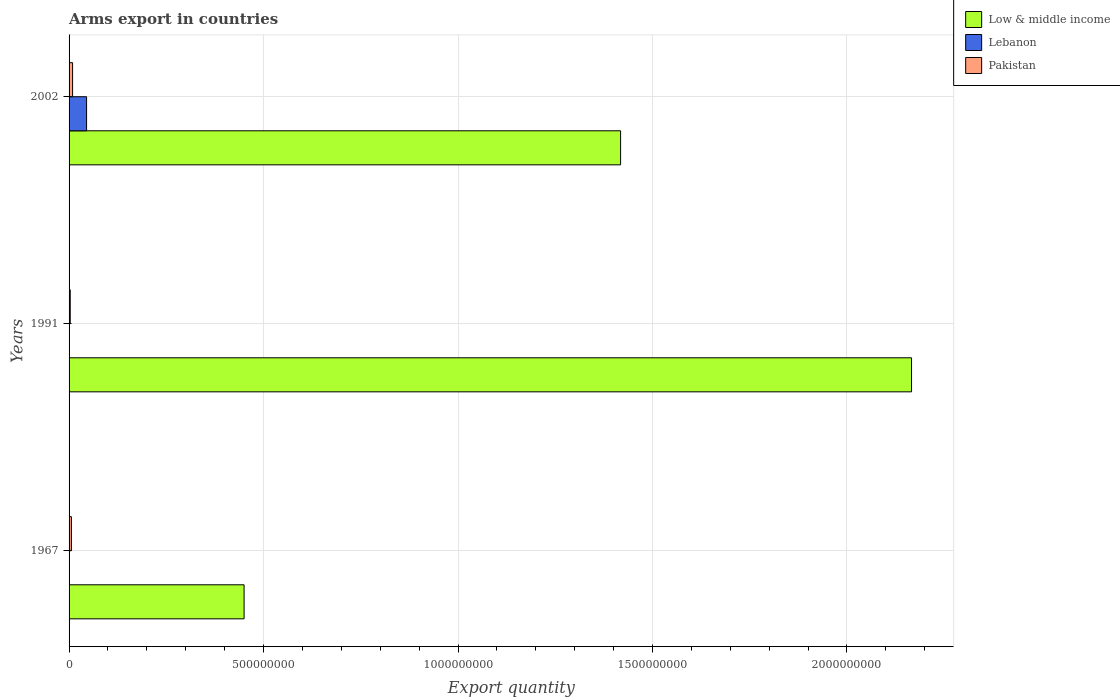How many groups of bars are there?
Offer a very short reply. 3. Are the number of bars per tick equal to the number of legend labels?
Ensure brevity in your answer.  Yes. Are the number of bars on each tick of the Y-axis equal?
Provide a short and direct response. Yes. How many bars are there on the 1st tick from the top?
Offer a terse response. 3. What is the label of the 1st group of bars from the top?
Your response must be concise. 2002. What is the total arms export in Lebanon in 2002?
Your response must be concise. 4.50e+07. Across all years, what is the maximum total arms export in Low & middle income?
Offer a terse response. 2.17e+09. Across all years, what is the minimum total arms export in Low & middle income?
Ensure brevity in your answer.  4.50e+08. In which year was the total arms export in Lebanon maximum?
Make the answer very short. 2002. In which year was the total arms export in Low & middle income minimum?
Your answer should be very brief. 1967. What is the total total arms export in Pakistan in the graph?
Your response must be concise. 1.80e+07. What is the difference between the total arms export in Lebanon in 1967 and that in 2002?
Give a very brief answer. -4.40e+07. What is the difference between the total arms export in Lebanon in 1967 and the total arms export in Pakistan in 2002?
Keep it short and to the point. -8.00e+06. What is the average total arms export in Low & middle income per year?
Your response must be concise. 1.34e+09. What is the ratio of the total arms export in Low & middle income in 1967 to that in 1991?
Provide a short and direct response. 0.21. Is the total arms export in Low & middle income in 1967 less than that in 1991?
Offer a terse response. Yes. Is the difference between the total arms export in Lebanon in 1967 and 1991 greater than the difference between the total arms export in Pakistan in 1967 and 1991?
Keep it short and to the point. No. What is the difference between the highest and the second highest total arms export in Lebanon?
Your answer should be very brief. 4.40e+07. What is the difference between the highest and the lowest total arms export in Pakistan?
Provide a succinct answer. 6.00e+06. Is the sum of the total arms export in Lebanon in 1967 and 2002 greater than the maximum total arms export in Pakistan across all years?
Make the answer very short. Yes. What does the 3rd bar from the top in 1991 represents?
Offer a terse response. Low & middle income. Is it the case that in every year, the sum of the total arms export in Lebanon and total arms export in Low & middle income is greater than the total arms export in Pakistan?
Provide a succinct answer. Yes. Are all the bars in the graph horizontal?
Ensure brevity in your answer.  Yes. How many years are there in the graph?
Keep it short and to the point. 3. What is the difference between two consecutive major ticks on the X-axis?
Make the answer very short. 5.00e+08. Does the graph contain any zero values?
Give a very brief answer. No. Does the graph contain grids?
Keep it short and to the point. Yes. How are the legend labels stacked?
Keep it short and to the point. Vertical. What is the title of the graph?
Provide a succinct answer. Arms export in countries. Does "Northern Mariana Islands" appear as one of the legend labels in the graph?
Your response must be concise. No. What is the label or title of the X-axis?
Provide a succinct answer. Export quantity. What is the Export quantity of Low & middle income in 1967?
Keep it short and to the point. 4.50e+08. What is the Export quantity of Lebanon in 1967?
Your response must be concise. 1.00e+06. What is the Export quantity in Low & middle income in 1991?
Your answer should be very brief. 2.17e+09. What is the Export quantity of Pakistan in 1991?
Keep it short and to the point. 3.00e+06. What is the Export quantity of Low & middle income in 2002?
Your answer should be very brief. 1.42e+09. What is the Export quantity in Lebanon in 2002?
Your response must be concise. 4.50e+07. What is the Export quantity in Pakistan in 2002?
Make the answer very short. 9.00e+06. Across all years, what is the maximum Export quantity of Low & middle income?
Ensure brevity in your answer.  2.17e+09. Across all years, what is the maximum Export quantity of Lebanon?
Provide a succinct answer. 4.50e+07. Across all years, what is the maximum Export quantity in Pakistan?
Provide a succinct answer. 9.00e+06. Across all years, what is the minimum Export quantity of Low & middle income?
Provide a short and direct response. 4.50e+08. Across all years, what is the minimum Export quantity of Pakistan?
Your answer should be compact. 3.00e+06. What is the total Export quantity of Low & middle income in the graph?
Offer a very short reply. 4.03e+09. What is the total Export quantity of Lebanon in the graph?
Your answer should be very brief. 4.70e+07. What is the total Export quantity of Pakistan in the graph?
Make the answer very short. 1.80e+07. What is the difference between the Export quantity of Low & middle income in 1967 and that in 1991?
Give a very brief answer. -1.72e+09. What is the difference between the Export quantity of Low & middle income in 1967 and that in 2002?
Your answer should be compact. -9.68e+08. What is the difference between the Export quantity of Lebanon in 1967 and that in 2002?
Keep it short and to the point. -4.40e+07. What is the difference between the Export quantity of Low & middle income in 1991 and that in 2002?
Offer a very short reply. 7.48e+08. What is the difference between the Export quantity in Lebanon in 1991 and that in 2002?
Offer a very short reply. -4.40e+07. What is the difference between the Export quantity in Pakistan in 1991 and that in 2002?
Give a very brief answer. -6.00e+06. What is the difference between the Export quantity in Low & middle income in 1967 and the Export quantity in Lebanon in 1991?
Provide a succinct answer. 4.49e+08. What is the difference between the Export quantity of Low & middle income in 1967 and the Export quantity of Pakistan in 1991?
Make the answer very short. 4.47e+08. What is the difference between the Export quantity in Lebanon in 1967 and the Export quantity in Pakistan in 1991?
Offer a very short reply. -2.00e+06. What is the difference between the Export quantity in Low & middle income in 1967 and the Export quantity in Lebanon in 2002?
Provide a succinct answer. 4.05e+08. What is the difference between the Export quantity in Low & middle income in 1967 and the Export quantity in Pakistan in 2002?
Provide a short and direct response. 4.41e+08. What is the difference between the Export quantity of Lebanon in 1967 and the Export quantity of Pakistan in 2002?
Ensure brevity in your answer.  -8.00e+06. What is the difference between the Export quantity in Low & middle income in 1991 and the Export quantity in Lebanon in 2002?
Your answer should be very brief. 2.12e+09. What is the difference between the Export quantity in Low & middle income in 1991 and the Export quantity in Pakistan in 2002?
Keep it short and to the point. 2.16e+09. What is the difference between the Export quantity of Lebanon in 1991 and the Export quantity of Pakistan in 2002?
Provide a short and direct response. -8.00e+06. What is the average Export quantity in Low & middle income per year?
Offer a terse response. 1.34e+09. What is the average Export quantity of Lebanon per year?
Provide a short and direct response. 1.57e+07. In the year 1967, what is the difference between the Export quantity in Low & middle income and Export quantity in Lebanon?
Keep it short and to the point. 4.49e+08. In the year 1967, what is the difference between the Export quantity in Low & middle income and Export quantity in Pakistan?
Offer a very short reply. 4.44e+08. In the year 1967, what is the difference between the Export quantity in Lebanon and Export quantity in Pakistan?
Keep it short and to the point. -5.00e+06. In the year 1991, what is the difference between the Export quantity of Low & middle income and Export quantity of Lebanon?
Your response must be concise. 2.16e+09. In the year 1991, what is the difference between the Export quantity of Low & middle income and Export quantity of Pakistan?
Give a very brief answer. 2.16e+09. In the year 2002, what is the difference between the Export quantity of Low & middle income and Export quantity of Lebanon?
Make the answer very short. 1.37e+09. In the year 2002, what is the difference between the Export quantity in Low & middle income and Export quantity in Pakistan?
Offer a very short reply. 1.41e+09. In the year 2002, what is the difference between the Export quantity of Lebanon and Export quantity of Pakistan?
Your answer should be compact. 3.60e+07. What is the ratio of the Export quantity of Low & middle income in 1967 to that in 1991?
Offer a terse response. 0.21. What is the ratio of the Export quantity of Lebanon in 1967 to that in 1991?
Provide a succinct answer. 1. What is the ratio of the Export quantity in Low & middle income in 1967 to that in 2002?
Your answer should be very brief. 0.32. What is the ratio of the Export quantity of Lebanon in 1967 to that in 2002?
Your answer should be compact. 0.02. What is the ratio of the Export quantity in Low & middle income in 1991 to that in 2002?
Keep it short and to the point. 1.53. What is the ratio of the Export quantity in Lebanon in 1991 to that in 2002?
Your answer should be compact. 0.02. What is the difference between the highest and the second highest Export quantity in Low & middle income?
Give a very brief answer. 7.48e+08. What is the difference between the highest and the second highest Export quantity in Lebanon?
Keep it short and to the point. 4.40e+07. What is the difference between the highest and the lowest Export quantity in Low & middle income?
Provide a succinct answer. 1.72e+09. What is the difference between the highest and the lowest Export quantity of Lebanon?
Offer a terse response. 4.40e+07. 